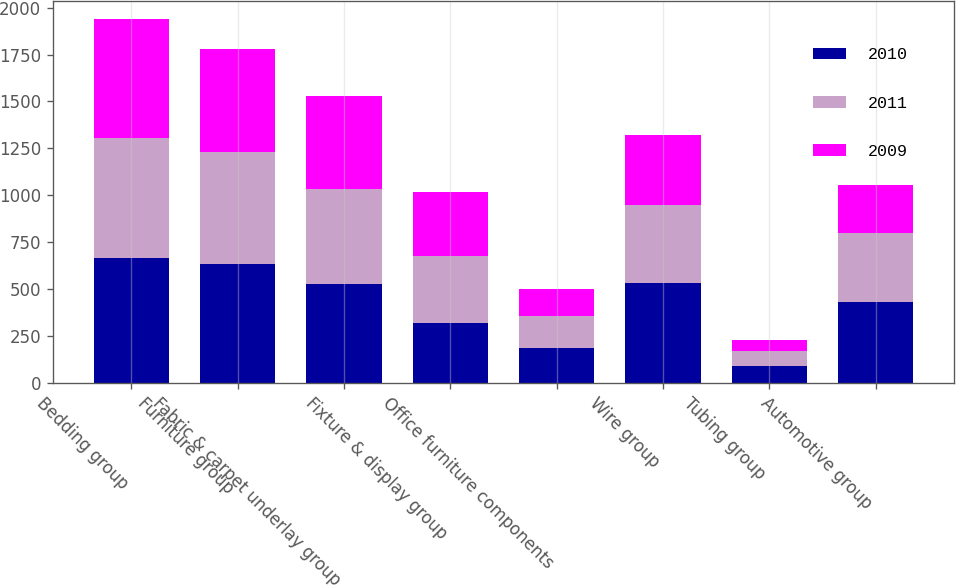Convert chart to OTSL. <chart><loc_0><loc_0><loc_500><loc_500><stacked_bar_chart><ecel><fcel>Bedding group<fcel>Furniture group<fcel>Fabric & carpet underlay group<fcel>Fixture & display group<fcel>Office furniture components<fcel>Wire group<fcel>Tubing group<fcel>Automotive group<nl><fcel>2010<fcel>667.2<fcel>633.6<fcel>527<fcel>315.7<fcel>186.7<fcel>529.8<fcel>86.9<fcel>428.7<nl><fcel>2011<fcel>638.6<fcel>596.8<fcel>503.9<fcel>360.2<fcel>170.5<fcel>418.4<fcel>79.6<fcel>368.9<nl><fcel>2009<fcel>635.1<fcel>549.6<fcel>500.1<fcel>342.4<fcel>144.7<fcel>374.3<fcel>63.3<fcel>255.5<nl></chart> 